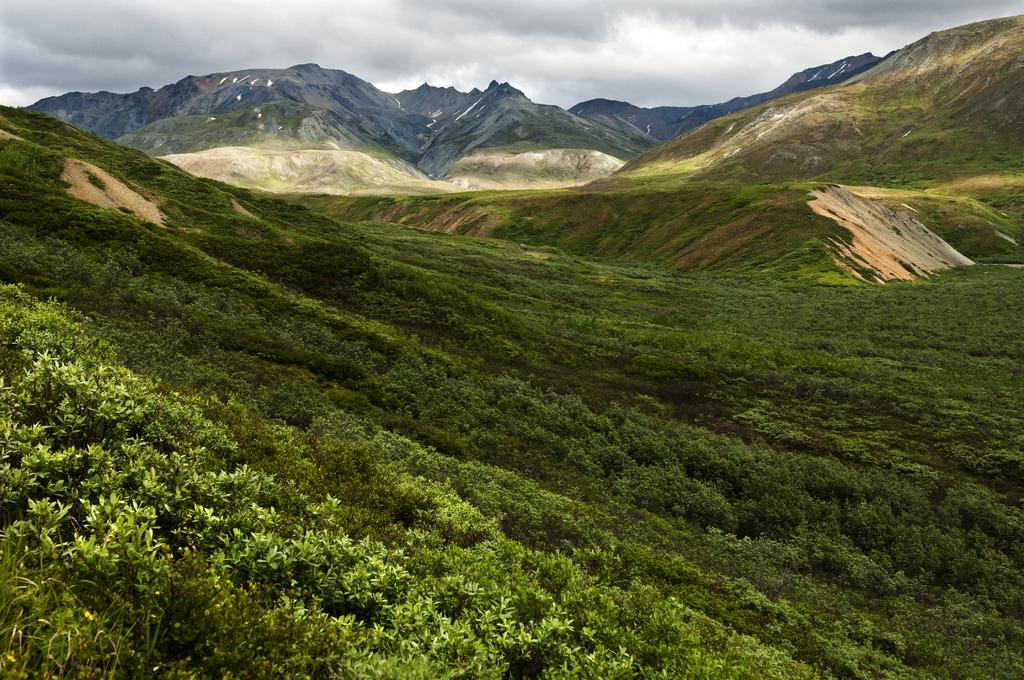What type of vegetation can be seen in the image? There are plants and grass in the image. What natural feature is visible in the background of the image? There are mountains in the image. What is visible in the sky in the image? The sky is visible in the background of the image, and there are clouds in the sky. How many lizards are sitting on the twig in the image? There are no lizards or twigs present in the image. 